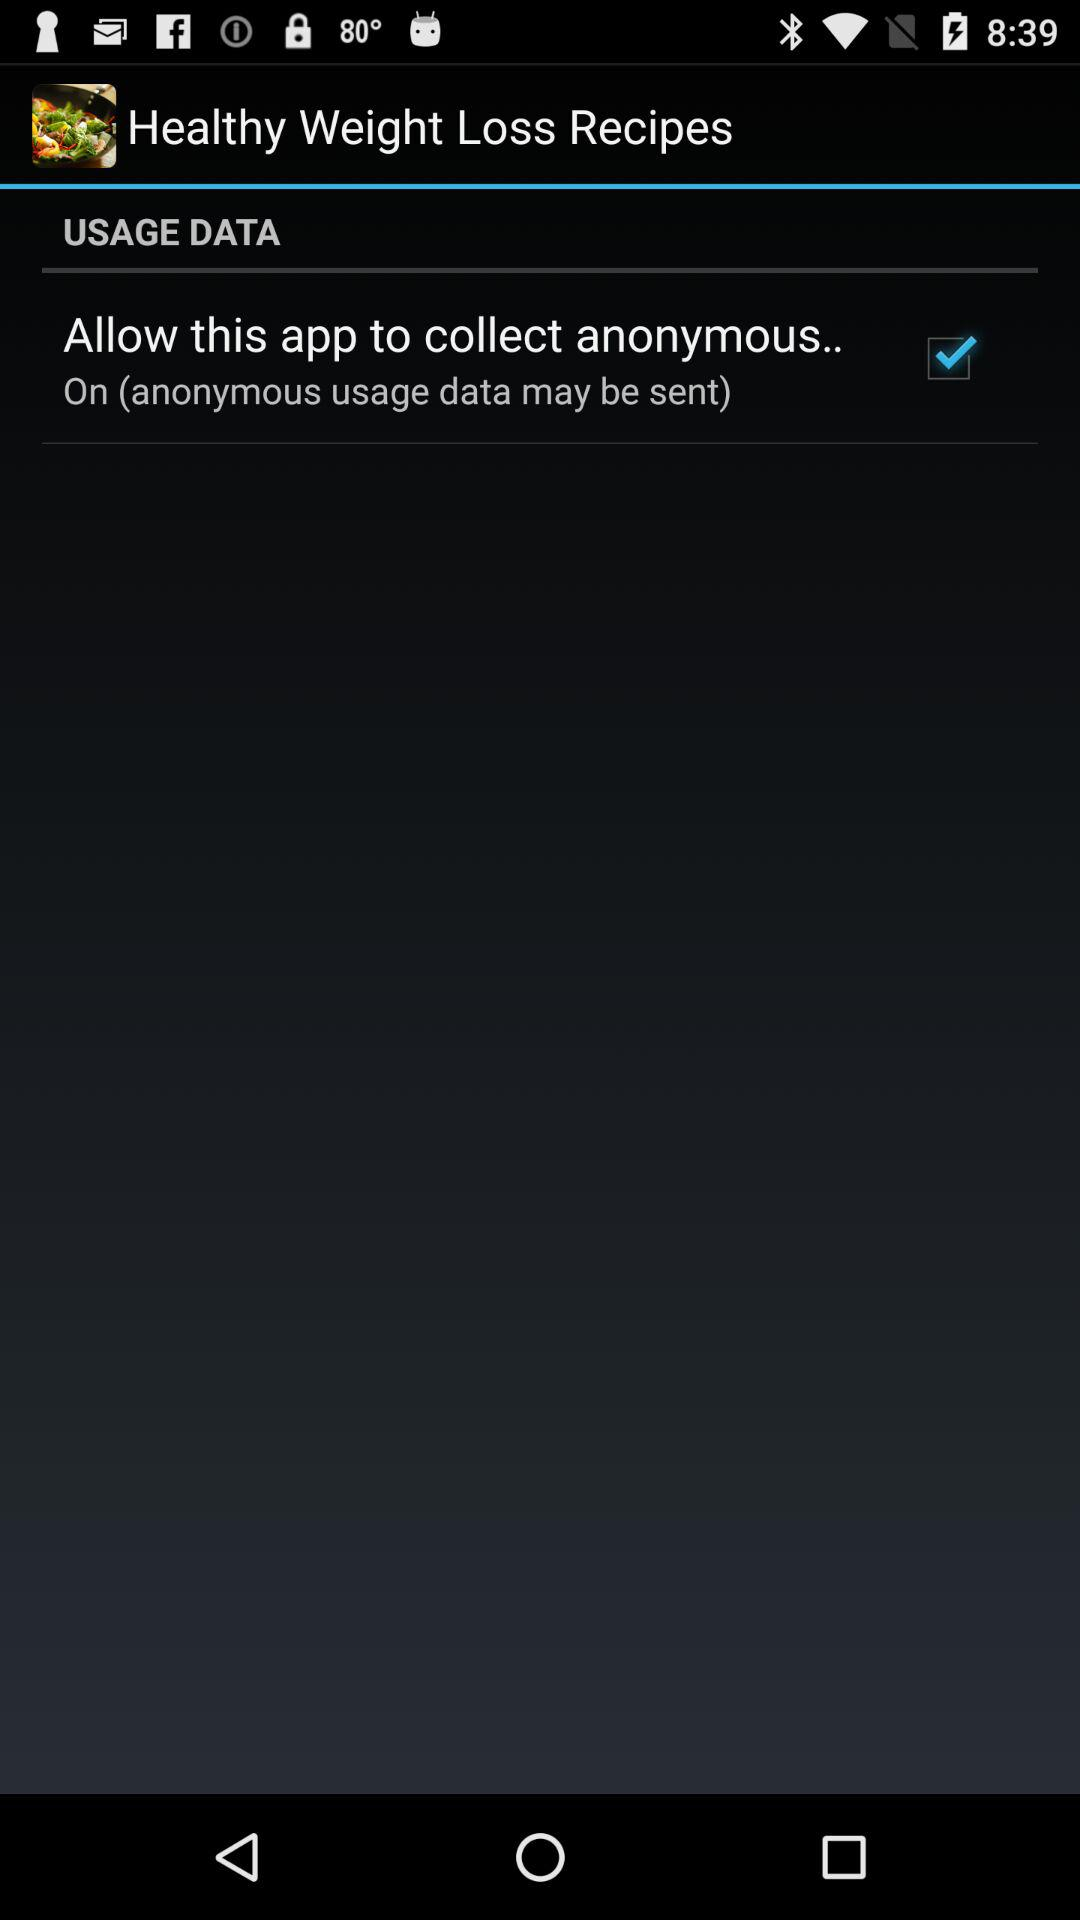What is the status of "Allow this app to collect anonymous.."? The status is "on". 